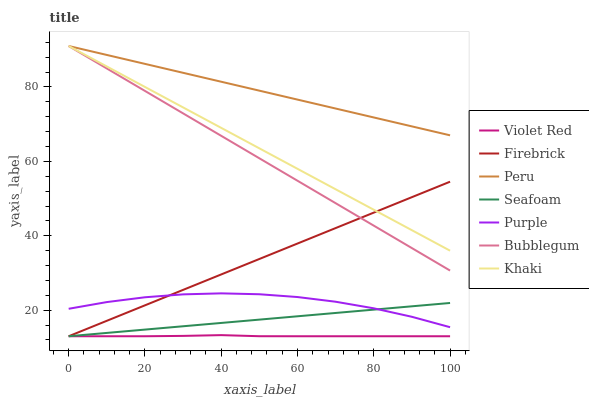Does Violet Red have the minimum area under the curve?
Answer yes or no. Yes. Does Peru have the maximum area under the curve?
Answer yes or no. Yes. Does Khaki have the minimum area under the curve?
Answer yes or no. No. Does Khaki have the maximum area under the curve?
Answer yes or no. No. Is Seafoam the smoothest?
Answer yes or no. Yes. Is Purple the roughest?
Answer yes or no. Yes. Is Khaki the smoothest?
Answer yes or no. No. Is Khaki the roughest?
Answer yes or no. No. Does Violet Red have the lowest value?
Answer yes or no. Yes. Does Khaki have the lowest value?
Answer yes or no. No. Does Peru have the highest value?
Answer yes or no. Yes. Does Purple have the highest value?
Answer yes or no. No. Is Violet Red less than Khaki?
Answer yes or no. Yes. Is Peru greater than Firebrick?
Answer yes or no. Yes. Does Khaki intersect Bubblegum?
Answer yes or no. Yes. Is Khaki less than Bubblegum?
Answer yes or no. No. Is Khaki greater than Bubblegum?
Answer yes or no. No. Does Violet Red intersect Khaki?
Answer yes or no. No. 